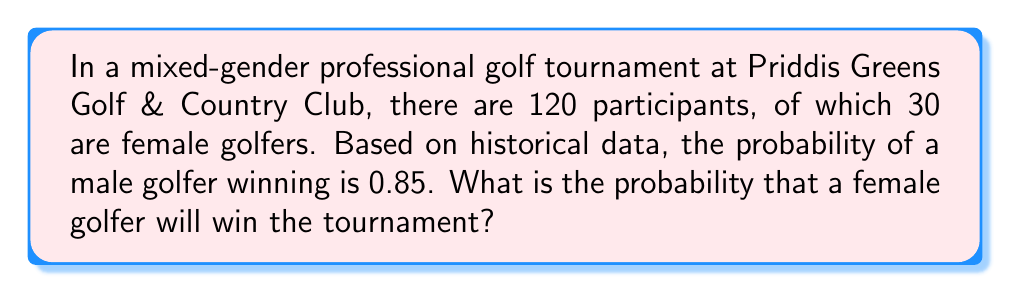Can you answer this question? Let's approach this step-by-step:

1) First, we need to understand what the question is asking. We're looking for the probability of a female golfer winning the tournament.

2) We're given that the probability of a male golfer winning is 0.85. This means that the probability of a male golfer not winning is 1 - 0.85 = 0.15.

3) In probability theory, if an event is not won by one group, it must be won by the other group (assuming there are only two groups). Therefore, the probability of a female golfer winning is equal to the probability of a male golfer not winning.

4) We can express this mathematically as:

   $P(\text{Female wins}) = 1 - P(\text{Male wins})$

5) Substituting the given probability:

   $P(\text{Female wins}) = 1 - 0.85 = 0.15$

6) To convert this to a percentage, we multiply by 100:

   $0.15 \times 100 = 15\%$

Therefore, the probability of a female golfer winning the tournament is 0.15 or 15%.

Note: This calculation assumes that the historical probability applies to this specific tournament and that the ratio of male to female participants doesn't significantly affect the outcome.
Answer: 0.15 or 15% 